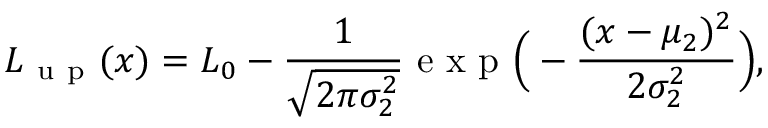<formula> <loc_0><loc_0><loc_500><loc_500>L _ { u p } ( x ) = L _ { 0 } - \frac { 1 } { \sqrt { 2 \pi \sigma _ { 2 } ^ { 2 } } } e x p \left ( - \frac { ( x - \mu _ { 2 } ) ^ { 2 } } { 2 \sigma _ { 2 } ^ { 2 } } \right ) ,</formula> 